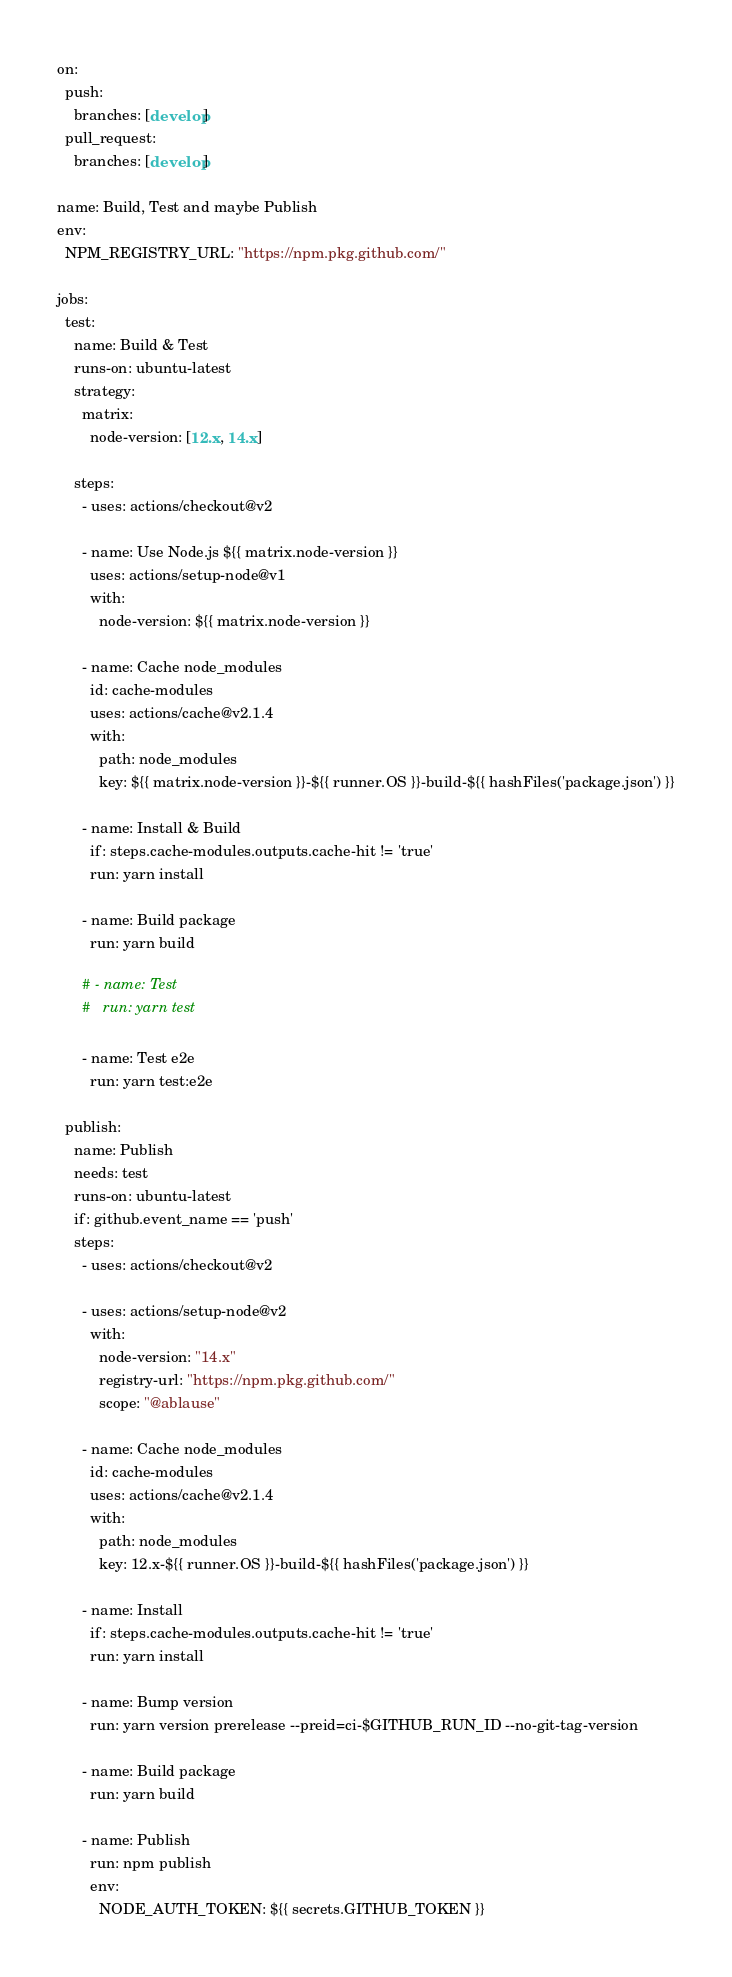<code> <loc_0><loc_0><loc_500><loc_500><_YAML_>on:
  push:
    branches: [develop]
  pull_request:
    branches: [develop]

name: Build, Test and maybe Publish
env:
  NPM_REGISTRY_URL: "https://npm.pkg.github.com/"

jobs:
  test:
    name: Build & Test
    runs-on: ubuntu-latest
    strategy:
      matrix:
        node-version: [12.x, 14.x]

    steps:
      - uses: actions/checkout@v2

      - name: Use Node.js ${{ matrix.node-version }}
        uses: actions/setup-node@v1
        with:
          node-version: ${{ matrix.node-version }}

      - name: Cache node_modules
        id: cache-modules
        uses: actions/cache@v2.1.4
        with:
          path: node_modules
          key: ${{ matrix.node-version }}-${{ runner.OS }}-build-${{ hashFiles('package.json') }}

      - name: Install & Build
        if: steps.cache-modules.outputs.cache-hit != 'true'
        run: yarn install

      - name: Build package
        run: yarn build

      # - name: Test
      #   run: yarn test

      - name: Test e2e
        run: yarn test:e2e

  publish:
    name: Publish
    needs: test
    runs-on: ubuntu-latest
    if: github.event_name == 'push'
    steps:
      - uses: actions/checkout@v2

      - uses: actions/setup-node@v2
        with:
          node-version: "14.x"
          registry-url: "https://npm.pkg.github.com/"
          scope: "@ablause"

      - name: Cache node_modules
        id: cache-modules
        uses: actions/cache@v2.1.4
        with:
          path: node_modules
          key: 12.x-${{ runner.OS }}-build-${{ hashFiles('package.json') }}

      - name: Install
        if: steps.cache-modules.outputs.cache-hit != 'true'
        run: yarn install

      - name: Bump version
        run: yarn version prerelease --preid=ci-$GITHUB_RUN_ID --no-git-tag-version

      - name: Build package
        run: yarn build

      - name: Publish
        run: npm publish
        env:
          NODE_AUTH_TOKEN: ${{ secrets.GITHUB_TOKEN }}
</code> 